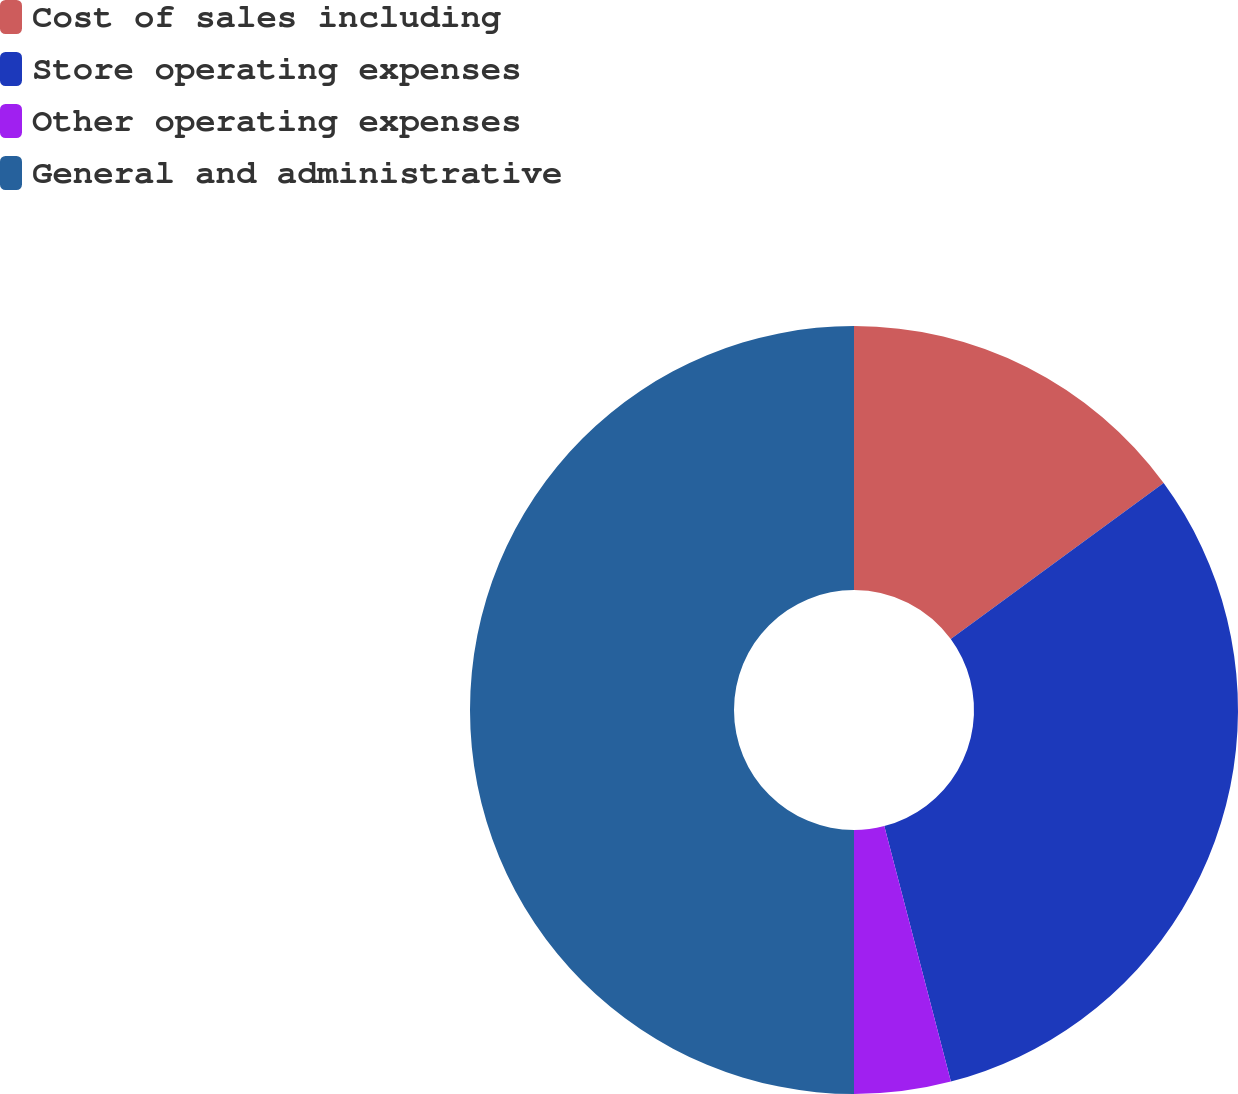Convert chart. <chart><loc_0><loc_0><loc_500><loc_500><pie_chart><fcel>Cost of sales including<fcel>Store operating expenses<fcel>Other operating expenses<fcel>General and administrative<nl><fcel>14.93%<fcel>31.01%<fcel>4.06%<fcel>50.0%<nl></chart> 